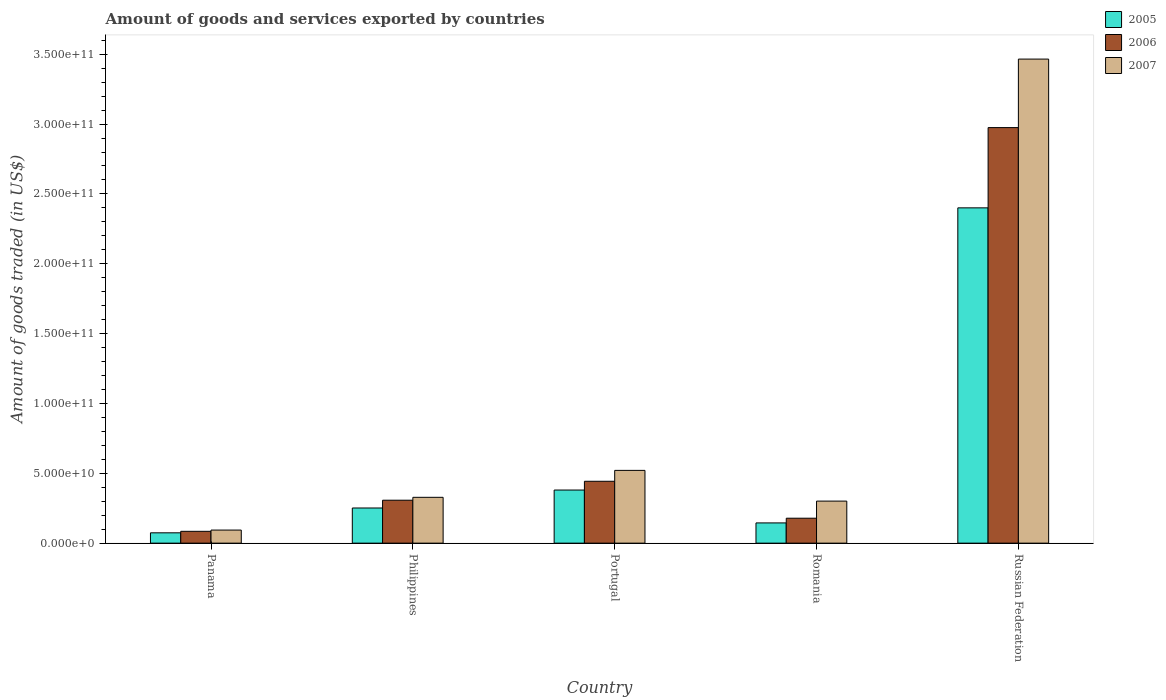How many different coloured bars are there?
Your answer should be very brief. 3. Are the number of bars per tick equal to the number of legend labels?
Make the answer very short. Yes. How many bars are there on the 1st tick from the left?
Keep it short and to the point. 3. How many bars are there on the 5th tick from the right?
Keep it short and to the point. 3. What is the label of the 3rd group of bars from the left?
Your answer should be compact. Portugal. What is the total amount of goods and services exported in 2007 in Philippines?
Make the answer very short. 3.28e+1. Across all countries, what is the maximum total amount of goods and services exported in 2006?
Your answer should be very brief. 2.97e+11. Across all countries, what is the minimum total amount of goods and services exported in 2006?
Your answer should be compact. 8.46e+09. In which country was the total amount of goods and services exported in 2005 maximum?
Offer a terse response. Russian Federation. In which country was the total amount of goods and services exported in 2005 minimum?
Make the answer very short. Panama. What is the total total amount of goods and services exported in 2007 in the graph?
Ensure brevity in your answer.  4.71e+11. What is the difference between the total amount of goods and services exported in 2007 in Panama and that in Russian Federation?
Give a very brief answer. -3.37e+11. What is the difference between the total amount of goods and services exported in 2007 in Portugal and the total amount of goods and services exported in 2006 in Russian Federation?
Your response must be concise. -2.45e+11. What is the average total amount of goods and services exported in 2005 per country?
Your answer should be very brief. 6.50e+1. What is the difference between the total amount of goods and services exported of/in 2007 and total amount of goods and services exported of/in 2006 in Philippines?
Your answer should be compact. 2.07e+09. In how many countries, is the total amount of goods and services exported in 2005 greater than 160000000000 US$?
Your response must be concise. 1. What is the ratio of the total amount of goods and services exported in 2005 in Portugal to that in Russian Federation?
Your response must be concise. 0.16. Is the total amount of goods and services exported in 2006 in Panama less than that in Russian Federation?
Provide a short and direct response. Yes. What is the difference between the highest and the second highest total amount of goods and services exported in 2005?
Provide a short and direct response. 2.15e+11. What is the difference between the highest and the lowest total amount of goods and services exported in 2005?
Give a very brief answer. 2.33e+11. Is the sum of the total amount of goods and services exported in 2007 in Panama and Portugal greater than the maximum total amount of goods and services exported in 2005 across all countries?
Give a very brief answer. No. What does the 2nd bar from the left in Portugal represents?
Ensure brevity in your answer.  2006. How many bars are there?
Ensure brevity in your answer.  15. Are all the bars in the graph horizontal?
Ensure brevity in your answer.  No. How many countries are there in the graph?
Make the answer very short. 5. Does the graph contain grids?
Make the answer very short. No. Where does the legend appear in the graph?
Provide a short and direct response. Top right. How are the legend labels stacked?
Offer a very short reply. Vertical. What is the title of the graph?
Keep it short and to the point. Amount of goods and services exported by countries. Does "1992" appear as one of the legend labels in the graph?
Offer a very short reply. No. What is the label or title of the X-axis?
Your answer should be compact. Country. What is the label or title of the Y-axis?
Offer a terse response. Amount of goods traded (in US$). What is the Amount of goods traded (in US$) in 2005 in Panama?
Your answer should be very brief. 7.39e+09. What is the Amount of goods traded (in US$) in 2006 in Panama?
Your answer should be compact. 8.46e+09. What is the Amount of goods traded (in US$) in 2007 in Panama?
Make the answer very short. 9.36e+09. What is the Amount of goods traded (in US$) of 2005 in Philippines?
Provide a succinct answer. 2.52e+1. What is the Amount of goods traded (in US$) in 2006 in Philippines?
Offer a very short reply. 3.07e+1. What is the Amount of goods traded (in US$) of 2007 in Philippines?
Offer a very short reply. 3.28e+1. What is the Amount of goods traded (in US$) of 2005 in Portugal?
Make the answer very short. 3.80e+1. What is the Amount of goods traded (in US$) of 2006 in Portugal?
Give a very brief answer. 4.43e+1. What is the Amount of goods traded (in US$) of 2007 in Portugal?
Ensure brevity in your answer.  5.21e+1. What is the Amount of goods traded (in US$) in 2005 in Romania?
Offer a very short reply. 1.45e+1. What is the Amount of goods traded (in US$) of 2006 in Romania?
Your response must be concise. 1.78e+1. What is the Amount of goods traded (in US$) in 2007 in Romania?
Provide a succinct answer. 3.01e+1. What is the Amount of goods traded (in US$) in 2005 in Russian Federation?
Give a very brief answer. 2.40e+11. What is the Amount of goods traded (in US$) in 2006 in Russian Federation?
Provide a succinct answer. 2.97e+11. What is the Amount of goods traded (in US$) in 2007 in Russian Federation?
Offer a terse response. 3.47e+11. Across all countries, what is the maximum Amount of goods traded (in US$) in 2005?
Offer a very short reply. 2.40e+11. Across all countries, what is the maximum Amount of goods traded (in US$) in 2006?
Offer a terse response. 2.97e+11. Across all countries, what is the maximum Amount of goods traded (in US$) of 2007?
Your response must be concise. 3.47e+11. Across all countries, what is the minimum Amount of goods traded (in US$) in 2005?
Provide a succinct answer. 7.39e+09. Across all countries, what is the minimum Amount of goods traded (in US$) in 2006?
Provide a short and direct response. 8.46e+09. Across all countries, what is the minimum Amount of goods traded (in US$) in 2007?
Give a very brief answer. 9.36e+09. What is the total Amount of goods traded (in US$) of 2005 in the graph?
Make the answer very short. 3.25e+11. What is the total Amount of goods traded (in US$) of 2006 in the graph?
Your response must be concise. 3.99e+11. What is the total Amount of goods traded (in US$) in 2007 in the graph?
Keep it short and to the point. 4.71e+11. What is the difference between the Amount of goods traded (in US$) in 2005 in Panama and that in Philippines?
Ensure brevity in your answer.  -1.78e+1. What is the difference between the Amount of goods traded (in US$) in 2006 in Panama and that in Philippines?
Offer a very short reply. -2.23e+1. What is the difference between the Amount of goods traded (in US$) in 2007 in Panama and that in Philippines?
Provide a succinct answer. -2.34e+1. What is the difference between the Amount of goods traded (in US$) of 2005 in Panama and that in Portugal?
Your answer should be very brief. -3.06e+1. What is the difference between the Amount of goods traded (in US$) of 2006 in Panama and that in Portugal?
Give a very brief answer. -3.58e+1. What is the difference between the Amount of goods traded (in US$) in 2007 in Panama and that in Portugal?
Ensure brevity in your answer.  -4.27e+1. What is the difference between the Amount of goods traded (in US$) in 2005 in Panama and that in Romania?
Offer a terse response. -7.10e+09. What is the difference between the Amount of goods traded (in US$) of 2006 in Panama and that in Romania?
Make the answer very short. -9.38e+09. What is the difference between the Amount of goods traded (in US$) in 2007 in Panama and that in Romania?
Provide a short and direct response. -2.07e+1. What is the difference between the Amount of goods traded (in US$) of 2005 in Panama and that in Russian Federation?
Provide a short and direct response. -2.33e+11. What is the difference between the Amount of goods traded (in US$) in 2006 in Panama and that in Russian Federation?
Ensure brevity in your answer.  -2.89e+11. What is the difference between the Amount of goods traded (in US$) of 2007 in Panama and that in Russian Federation?
Your answer should be very brief. -3.37e+11. What is the difference between the Amount of goods traded (in US$) of 2005 in Philippines and that in Portugal?
Provide a short and direct response. -1.29e+1. What is the difference between the Amount of goods traded (in US$) in 2006 in Philippines and that in Portugal?
Keep it short and to the point. -1.36e+1. What is the difference between the Amount of goods traded (in US$) of 2007 in Philippines and that in Portugal?
Provide a short and direct response. -1.93e+1. What is the difference between the Amount of goods traded (in US$) in 2005 in Philippines and that in Romania?
Make the answer very short. 1.07e+1. What is the difference between the Amount of goods traded (in US$) in 2006 in Philippines and that in Romania?
Provide a short and direct response. 1.29e+1. What is the difference between the Amount of goods traded (in US$) of 2007 in Philippines and that in Romania?
Your response must be concise. 2.70e+09. What is the difference between the Amount of goods traded (in US$) in 2005 in Philippines and that in Russian Federation?
Your answer should be compact. -2.15e+11. What is the difference between the Amount of goods traded (in US$) in 2006 in Philippines and that in Russian Federation?
Provide a succinct answer. -2.67e+11. What is the difference between the Amount of goods traded (in US$) of 2007 in Philippines and that in Russian Federation?
Make the answer very short. -3.14e+11. What is the difference between the Amount of goods traded (in US$) of 2005 in Portugal and that in Romania?
Provide a succinct answer. 2.35e+1. What is the difference between the Amount of goods traded (in US$) in 2006 in Portugal and that in Romania?
Give a very brief answer. 2.65e+1. What is the difference between the Amount of goods traded (in US$) in 2007 in Portugal and that in Romania?
Make the answer very short. 2.20e+1. What is the difference between the Amount of goods traded (in US$) of 2005 in Portugal and that in Russian Federation?
Keep it short and to the point. -2.02e+11. What is the difference between the Amount of goods traded (in US$) in 2006 in Portugal and that in Russian Federation?
Provide a succinct answer. -2.53e+11. What is the difference between the Amount of goods traded (in US$) of 2007 in Portugal and that in Russian Federation?
Provide a short and direct response. -2.94e+11. What is the difference between the Amount of goods traded (in US$) in 2005 in Romania and that in Russian Federation?
Ensure brevity in your answer.  -2.26e+11. What is the difference between the Amount of goods traded (in US$) in 2006 in Romania and that in Russian Federation?
Offer a terse response. -2.80e+11. What is the difference between the Amount of goods traded (in US$) of 2007 in Romania and that in Russian Federation?
Provide a succinct answer. -3.16e+11. What is the difference between the Amount of goods traded (in US$) of 2005 in Panama and the Amount of goods traded (in US$) of 2006 in Philippines?
Give a very brief answer. -2.33e+1. What is the difference between the Amount of goods traded (in US$) in 2005 in Panama and the Amount of goods traded (in US$) in 2007 in Philippines?
Provide a succinct answer. -2.54e+1. What is the difference between the Amount of goods traded (in US$) in 2006 in Panama and the Amount of goods traded (in US$) in 2007 in Philippines?
Make the answer very short. -2.43e+1. What is the difference between the Amount of goods traded (in US$) in 2005 in Panama and the Amount of goods traded (in US$) in 2006 in Portugal?
Your response must be concise. -3.69e+1. What is the difference between the Amount of goods traded (in US$) in 2005 in Panama and the Amount of goods traded (in US$) in 2007 in Portugal?
Give a very brief answer. -4.47e+1. What is the difference between the Amount of goods traded (in US$) of 2006 in Panama and the Amount of goods traded (in US$) of 2007 in Portugal?
Your answer should be very brief. -4.36e+1. What is the difference between the Amount of goods traded (in US$) of 2005 in Panama and the Amount of goods traded (in US$) of 2006 in Romania?
Offer a terse response. -1.05e+1. What is the difference between the Amount of goods traded (in US$) in 2005 in Panama and the Amount of goods traded (in US$) in 2007 in Romania?
Make the answer very short. -2.27e+1. What is the difference between the Amount of goods traded (in US$) in 2006 in Panama and the Amount of goods traded (in US$) in 2007 in Romania?
Your response must be concise. -2.16e+1. What is the difference between the Amount of goods traded (in US$) in 2005 in Panama and the Amount of goods traded (in US$) in 2006 in Russian Federation?
Ensure brevity in your answer.  -2.90e+11. What is the difference between the Amount of goods traded (in US$) in 2005 in Panama and the Amount of goods traded (in US$) in 2007 in Russian Federation?
Provide a short and direct response. -3.39e+11. What is the difference between the Amount of goods traded (in US$) of 2006 in Panama and the Amount of goods traded (in US$) of 2007 in Russian Federation?
Offer a very short reply. -3.38e+11. What is the difference between the Amount of goods traded (in US$) in 2005 in Philippines and the Amount of goods traded (in US$) in 2006 in Portugal?
Your response must be concise. -1.91e+1. What is the difference between the Amount of goods traded (in US$) in 2005 in Philippines and the Amount of goods traded (in US$) in 2007 in Portugal?
Offer a very short reply. -2.69e+1. What is the difference between the Amount of goods traded (in US$) of 2006 in Philippines and the Amount of goods traded (in US$) of 2007 in Portugal?
Offer a very short reply. -2.14e+1. What is the difference between the Amount of goods traded (in US$) in 2005 in Philippines and the Amount of goods traded (in US$) in 2006 in Romania?
Keep it short and to the point. 7.32e+09. What is the difference between the Amount of goods traded (in US$) in 2005 in Philippines and the Amount of goods traded (in US$) in 2007 in Romania?
Your answer should be compact. -4.94e+09. What is the difference between the Amount of goods traded (in US$) in 2006 in Philippines and the Amount of goods traded (in US$) in 2007 in Romania?
Your answer should be very brief. 6.36e+08. What is the difference between the Amount of goods traded (in US$) of 2005 in Philippines and the Amount of goods traded (in US$) of 2006 in Russian Federation?
Your answer should be very brief. -2.72e+11. What is the difference between the Amount of goods traded (in US$) in 2005 in Philippines and the Amount of goods traded (in US$) in 2007 in Russian Federation?
Your response must be concise. -3.21e+11. What is the difference between the Amount of goods traded (in US$) in 2006 in Philippines and the Amount of goods traded (in US$) in 2007 in Russian Federation?
Provide a short and direct response. -3.16e+11. What is the difference between the Amount of goods traded (in US$) of 2005 in Portugal and the Amount of goods traded (in US$) of 2006 in Romania?
Offer a terse response. 2.02e+1. What is the difference between the Amount of goods traded (in US$) of 2005 in Portugal and the Amount of goods traded (in US$) of 2007 in Romania?
Provide a succinct answer. 7.92e+09. What is the difference between the Amount of goods traded (in US$) of 2006 in Portugal and the Amount of goods traded (in US$) of 2007 in Romania?
Offer a terse response. 1.42e+1. What is the difference between the Amount of goods traded (in US$) in 2005 in Portugal and the Amount of goods traded (in US$) in 2006 in Russian Federation?
Make the answer very short. -2.59e+11. What is the difference between the Amount of goods traded (in US$) in 2005 in Portugal and the Amount of goods traded (in US$) in 2007 in Russian Federation?
Give a very brief answer. -3.09e+11. What is the difference between the Amount of goods traded (in US$) of 2006 in Portugal and the Amount of goods traded (in US$) of 2007 in Russian Federation?
Your answer should be very brief. -3.02e+11. What is the difference between the Amount of goods traded (in US$) in 2005 in Romania and the Amount of goods traded (in US$) in 2006 in Russian Federation?
Provide a short and direct response. -2.83e+11. What is the difference between the Amount of goods traded (in US$) of 2005 in Romania and the Amount of goods traded (in US$) of 2007 in Russian Federation?
Your answer should be compact. -3.32e+11. What is the difference between the Amount of goods traded (in US$) in 2006 in Romania and the Amount of goods traded (in US$) in 2007 in Russian Federation?
Your response must be concise. -3.29e+11. What is the average Amount of goods traded (in US$) in 2005 per country?
Provide a short and direct response. 6.50e+1. What is the average Amount of goods traded (in US$) of 2006 per country?
Give a very brief answer. 7.98e+1. What is the average Amount of goods traded (in US$) of 2007 per country?
Your answer should be very brief. 9.42e+1. What is the difference between the Amount of goods traded (in US$) of 2005 and Amount of goods traded (in US$) of 2006 in Panama?
Your response must be concise. -1.08e+09. What is the difference between the Amount of goods traded (in US$) in 2005 and Amount of goods traded (in US$) in 2007 in Panama?
Your answer should be compact. -1.97e+09. What is the difference between the Amount of goods traded (in US$) in 2006 and Amount of goods traded (in US$) in 2007 in Panama?
Your response must be concise. -8.94e+08. What is the difference between the Amount of goods traded (in US$) in 2005 and Amount of goods traded (in US$) in 2006 in Philippines?
Your answer should be very brief. -5.57e+09. What is the difference between the Amount of goods traded (in US$) of 2005 and Amount of goods traded (in US$) of 2007 in Philippines?
Provide a succinct answer. -7.64e+09. What is the difference between the Amount of goods traded (in US$) of 2006 and Amount of goods traded (in US$) of 2007 in Philippines?
Keep it short and to the point. -2.07e+09. What is the difference between the Amount of goods traded (in US$) in 2005 and Amount of goods traded (in US$) in 2006 in Portugal?
Ensure brevity in your answer.  -6.27e+09. What is the difference between the Amount of goods traded (in US$) of 2005 and Amount of goods traded (in US$) of 2007 in Portugal?
Your response must be concise. -1.41e+1. What is the difference between the Amount of goods traded (in US$) of 2006 and Amount of goods traded (in US$) of 2007 in Portugal?
Provide a short and direct response. -7.79e+09. What is the difference between the Amount of goods traded (in US$) in 2005 and Amount of goods traded (in US$) in 2006 in Romania?
Offer a terse response. -3.36e+09. What is the difference between the Amount of goods traded (in US$) of 2005 and Amount of goods traded (in US$) of 2007 in Romania?
Offer a terse response. -1.56e+1. What is the difference between the Amount of goods traded (in US$) in 2006 and Amount of goods traded (in US$) in 2007 in Romania?
Keep it short and to the point. -1.23e+1. What is the difference between the Amount of goods traded (in US$) in 2005 and Amount of goods traded (in US$) in 2006 in Russian Federation?
Your response must be concise. -5.75e+1. What is the difference between the Amount of goods traded (in US$) in 2005 and Amount of goods traded (in US$) in 2007 in Russian Federation?
Offer a terse response. -1.07e+11. What is the difference between the Amount of goods traded (in US$) in 2006 and Amount of goods traded (in US$) in 2007 in Russian Federation?
Offer a very short reply. -4.90e+1. What is the ratio of the Amount of goods traded (in US$) in 2005 in Panama to that in Philippines?
Make the answer very short. 0.29. What is the ratio of the Amount of goods traded (in US$) of 2006 in Panama to that in Philippines?
Provide a short and direct response. 0.28. What is the ratio of the Amount of goods traded (in US$) of 2007 in Panama to that in Philippines?
Give a very brief answer. 0.29. What is the ratio of the Amount of goods traded (in US$) in 2005 in Panama to that in Portugal?
Give a very brief answer. 0.19. What is the ratio of the Amount of goods traded (in US$) in 2006 in Panama to that in Portugal?
Your response must be concise. 0.19. What is the ratio of the Amount of goods traded (in US$) of 2007 in Panama to that in Portugal?
Your answer should be very brief. 0.18. What is the ratio of the Amount of goods traded (in US$) of 2005 in Panama to that in Romania?
Provide a succinct answer. 0.51. What is the ratio of the Amount of goods traded (in US$) in 2006 in Panama to that in Romania?
Keep it short and to the point. 0.47. What is the ratio of the Amount of goods traded (in US$) of 2007 in Panama to that in Romania?
Offer a terse response. 0.31. What is the ratio of the Amount of goods traded (in US$) in 2005 in Panama to that in Russian Federation?
Provide a succinct answer. 0.03. What is the ratio of the Amount of goods traded (in US$) of 2006 in Panama to that in Russian Federation?
Keep it short and to the point. 0.03. What is the ratio of the Amount of goods traded (in US$) in 2007 in Panama to that in Russian Federation?
Give a very brief answer. 0.03. What is the ratio of the Amount of goods traded (in US$) of 2005 in Philippines to that in Portugal?
Your answer should be very brief. 0.66. What is the ratio of the Amount of goods traded (in US$) in 2006 in Philippines to that in Portugal?
Give a very brief answer. 0.69. What is the ratio of the Amount of goods traded (in US$) of 2007 in Philippines to that in Portugal?
Offer a very short reply. 0.63. What is the ratio of the Amount of goods traded (in US$) of 2005 in Philippines to that in Romania?
Keep it short and to the point. 1.74. What is the ratio of the Amount of goods traded (in US$) of 2006 in Philippines to that in Romania?
Make the answer very short. 1.72. What is the ratio of the Amount of goods traded (in US$) in 2007 in Philippines to that in Romania?
Provide a short and direct response. 1.09. What is the ratio of the Amount of goods traded (in US$) of 2005 in Philippines to that in Russian Federation?
Give a very brief answer. 0.1. What is the ratio of the Amount of goods traded (in US$) in 2006 in Philippines to that in Russian Federation?
Ensure brevity in your answer.  0.1. What is the ratio of the Amount of goods traded (in US$) of 2007 in Philippines to that in Russian Federation?
Make the answer very short. 0.09. What is the ratio of the Amount of goods traded (in US$) in 2005 in Portugal to that in Romania?
Ensure brevity in your answer.  2.62. What is the ratio of the Amount of goods traded (in US$) in 2006 in Portugal to that in Romania?
Ensure brevity in your answer.  2.48. What is the ratio of the Amount of goods traded (in US$) of 2007 in Portugal to that in Romania?
Your answer should be very brief. 1.73. What is the ratio of the Amount of goods traded (in US$) in 2005 in Portugal to that in Russian Federation?
Offer a terse response. 0.16. What is the ratio of the Amount of goods traded (in US$) of 2006 in Portugal to that in Russian Federation?
Keep it short and to the point. 0.15. What is the ratio of the Amount of goods traded (in US$) of 2007 in Portugal to that in Russian Federation?
Give a very brief answer. 0.15. What is the ratio of the Amount of goods traded (in US$) in 2005 in Romania to that in Russian Federation?
Your answer should be compact. 0.06. What is the ratio of the Amount of goods traded (in US$) of 2006 in Romania to that in Russian Federation?
Offer a very short reply. 0.06. What is the ratio of the Amount of goods traded (in US$) of 2007 in Romania to that in Russian Federation?
Provide a short and direct response. 0.09. What is the difference between the highest and the second highest Amount of goods traded (in US$) in 2005?
Ensure brevity in your answer.  2.02e+11. What is the difference between the highest and the second highest Amount of goods traded (in US$) in 2006?
Your answer should be compact. 2.53e+11. What is the difference between the highest and the second highest Amount of goods traded (in US$) of 2007?
Make the answer very short. 2.94e+11. What is the difference between the highest and the lowest Amount of goods traded (in US$) of 2005?
Make the answer very short. 2.33e+11. What is the difference between the highest and the lowest Amount of goods traded (in US$) of 2006?
Offer a terse response. 2.89e+11. What is the difference between the highest and the lowest Amount of goods traded (in US$) of 2007?
Offer a very short reply. 3.37e+11. 